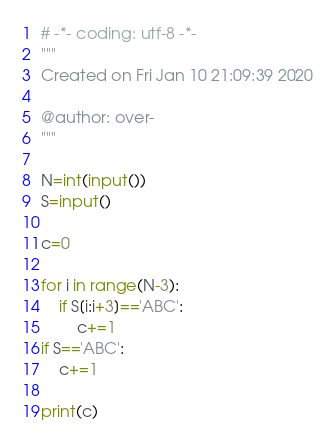<code> <loc_0><loc_0><loc_500><loc_500><_Python_># -*- coding: utf-8 -*-
"""
Created on Fri Jan 10 21:09:39 2020

@author: over-
"""

N=int(input())
S=input()

c=0

for i in range(N-3):
    if S[i:i+3]=='ABC':
        c+=1
if S=='ABC':
    c+=1        
        
print(c)</code> 